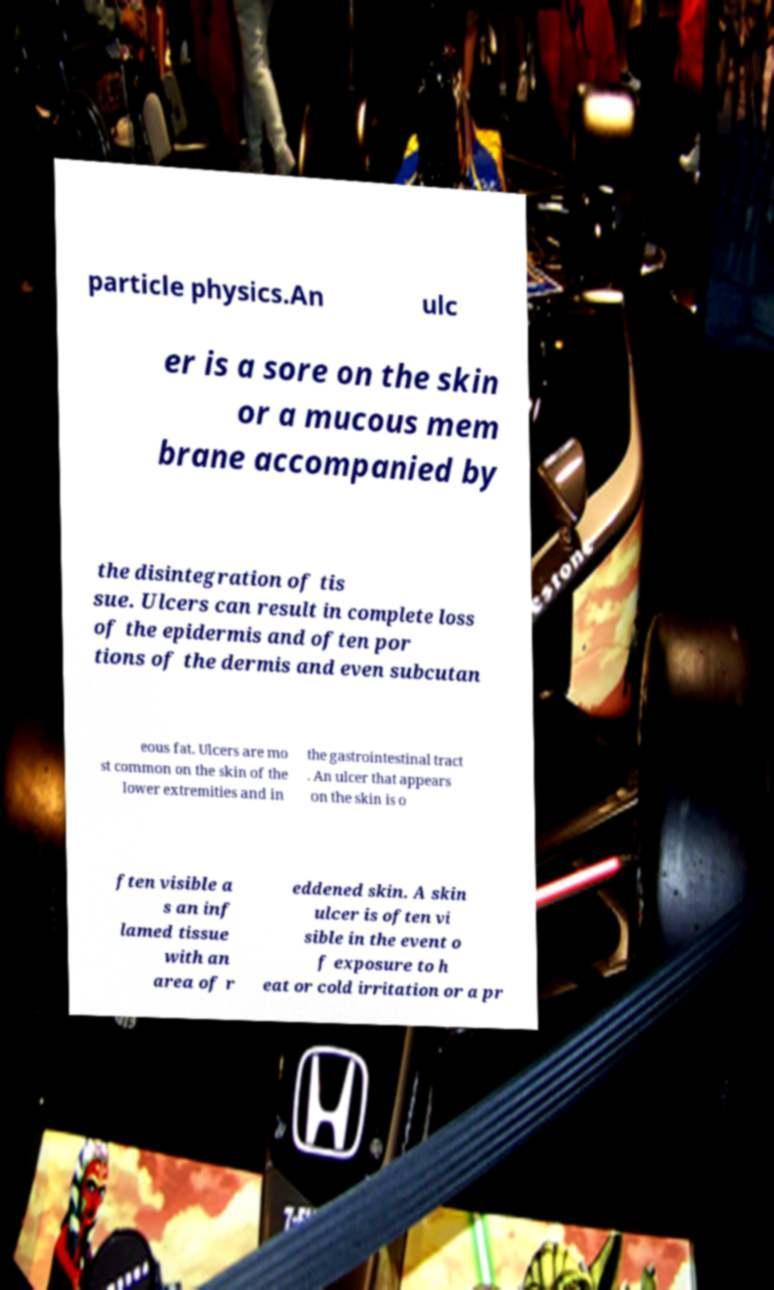Can you accurately transcribe the text from the provided image for me? particle physics.An ulc er is a sore on the skin or a mucous mem brane accompanied by the disintegration of tis sue. Ulcers can result in complete loss of the epidermis and often por tions of the dermis and even subcutan eous fat. Ulcers are mo st common on the skin of the lower extremities and in the gastrointestinal tract . An ulcer that appears on the skin is o ften visible a s an inf lamed tissue with an area of r eddened skin. A skin ulcer is often vi sible in the event o f exposure to h eat or cold irritation or a pr 